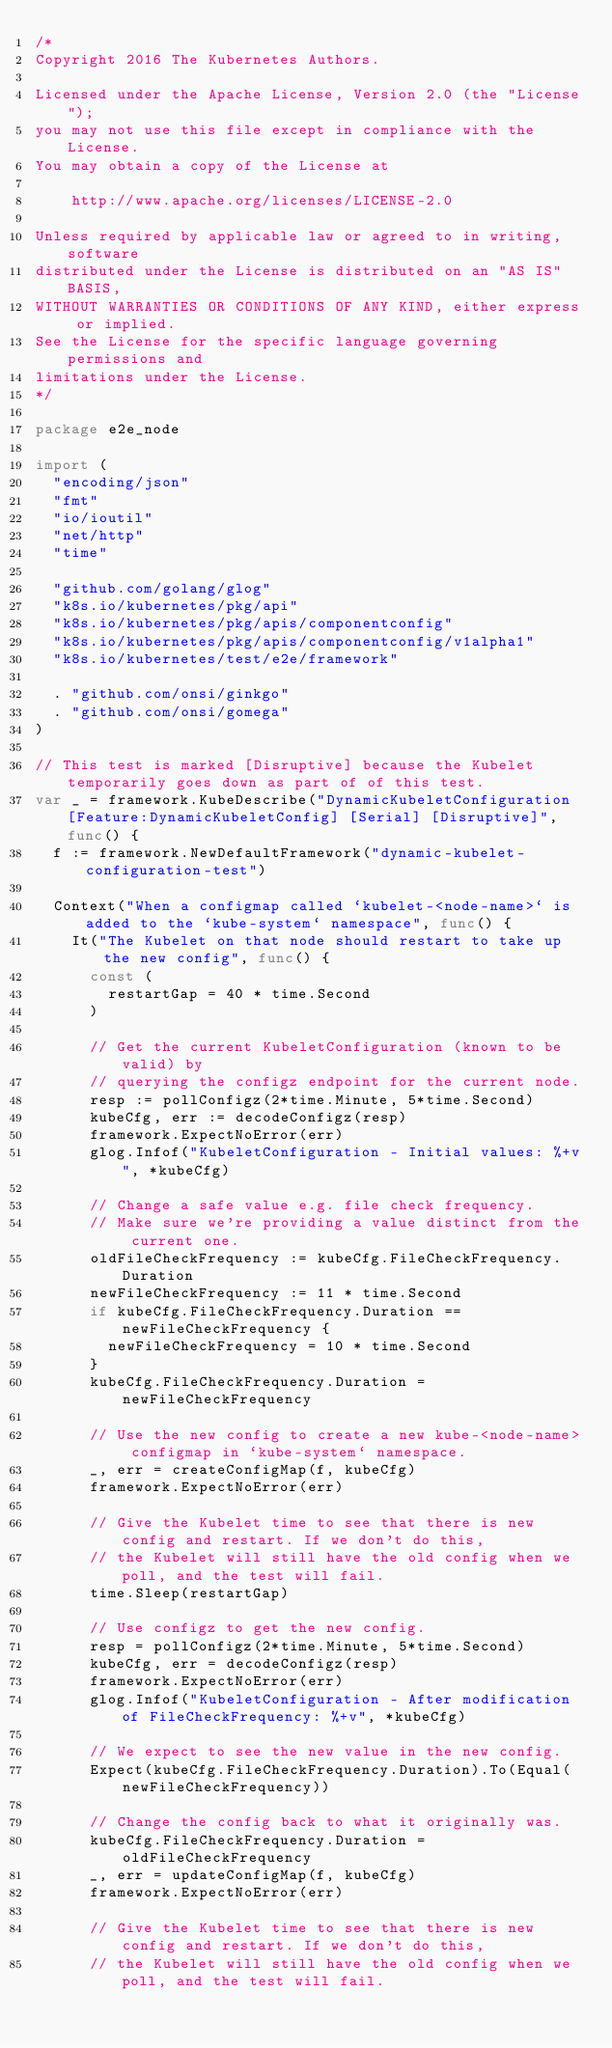Convert code to text. <code><loc_0><loc_0><loc_500><loc_500><_Go_>/*
Copyright 2016 The Kubernetes Authors.

Licensed under the Apache License, Version 2.0 (the "License");
you may not use this file except in compliance with the License.
You may obtain a copy of the License at

    http://www.apache.org/licenses/LICENSE-2.0

Unless required by applicable law or agreed to in writing, software
distributed under the License is distributed on an "AS IS" BASIS,
WITHOUT WARRANTIES OR CONDITIONS OF ANY KIND, either express or implied.
See the License for the specific language governing permissions and
limitations under the License.
*/

package e2e_node

import (
	"encoding/json"
	"fmt"
	"io/ioutil"
	"net/http"
	"time"

	"github.com/golang/glog"
	"k8s.io/kubernetes/pkg/api"
	"k8s.io/kubernetes/pkg/apis/componentconfig"
	"k8s.io/kubernetes/pkg/apis/componentconfig/v1alpha1"
	"k8s.io/kubernetes/test/e2e/framework"

	. "github.com/onsi/ginkgo"
	. "github.com/onsi/gomega"
)

// This test is marked [Disruptive] because the Kubelet temporarily goes down as part of of this test.
var _ = framework.KubeDescribe("DynamicKubeletConfiguration [Feature:DynamicKubeletConfig] [Serial] [Disruptive]", func() {
	f := framework.NewDefaultFramework("dynamic-kubelet-configuration-test")

	Context("When a configmap called `kubelet-<node-name>` is added to the `kube-system` namespace", func() {
		It("The Kubelet on that node should restart to take up the new config", func() {
			const (
				restartGap = 40 * time.Second
			)

			// Get the current KubeletConfiguration (known to be valid) by
			// querying the configz endpoint for the current node.
			resp := pollConfigz(2*time.Minute, 5*time.Second)
			kubeCfg, err := decodeConfigz(resp)
			framework.ExpectNoError(err)
			glog.Infof("KubeletConfiguration - Initial values: %+v", *kubeCfg)

			// Change a safe value e.g. file check frequency.
			// Make sure we're providing a value distinct from the current one.
			oldFileCheckFrequency := kubeCfg.FileCheckFrequency.Duration
			newFileCheckFrequency := 11 * time.Second
			if kubeCfg.FileCheckFrequency.Duration == newFileCheckFrequency {
				newFileCheckFrequency = 10 * time.Second
			}
			kubeCfg.FileCheckFrequency.Duration = newFileCheckFrequency

			// Use the new config to create a new kube-<node-name> configmap in `kube-system` namespace.
			_, err = createConfigMap(f, kubeCfg)
			framework.ExpectNoError(err)

			// Give the Kubelet time to see that there is new config and restart. If we don't do this,
			// the Kubelet will still have the old config when we poll, and the test will fail.
			time.Sleep(restartGap)

			// Use configz to get the new config.
			resp = pollConfigz(2*time.Minute, 5*time.Second)
			kubeCfg, err = decodeConfigz(resp)
			framework.ExpectNoError(err)
			glog.Infof("KubeletConfiguration - After modification of FileCheckFrequency: %+v", *kubeCfg)

			// We expect to see the new value in the new config.
			Expect(kubeCfg.FileCheckFrequency.Duration).To(Equal(newFileCheckFrequency))

			// Change the config back to what it originally was.
			kubeCfg.FileCheckFrequency.Duration = oldFileCheckFrequency
			_, err = updateConfigMap(f, kubeCfg)
			framework.ExpectNoError(err)

			// Give the Kubelet time to see that there is new config and restart. If we don't do this,
			// the Kubelet will still have the old config when we poll, and the test will fail.</code> 